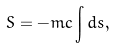Convert formula to latex. <formula><loc_0><loc_0><loc_500><loc_500>S = - m c \int d s ,</formula> 